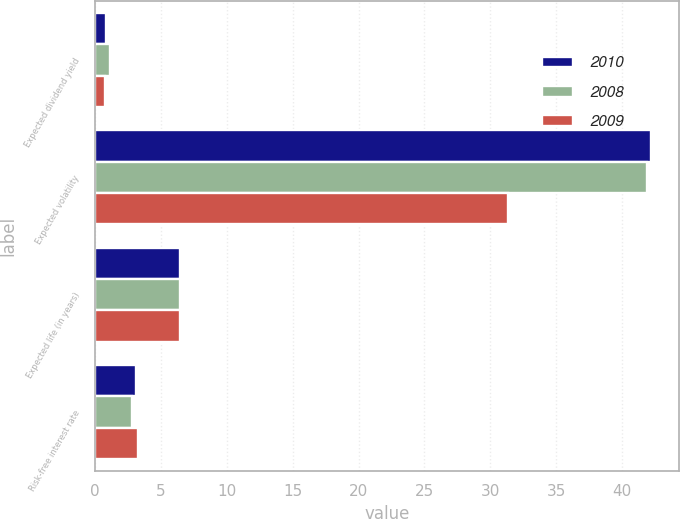Convert chart to OTSL. <chart><loc_0><loc_0><loc_500><loc_500><stacked_bar_chart><ecel><fcel>Expected dividend yield<fcel>Expected volatility<fcel>Expected life (in years)<fcel>Risk-free interest rate<nl><fcel>2010<fcel>0.87<fcel>42.17<fcel>6.5<fcel>3.13<nl><fcel>2008<fcel>1.13<fcel>41.9<fcel>6.5<fcel>2.82<nl><fcel>2009<fcel>0.75<fcel>31.3<fcel>6.5<fcel>3.26<nl></chart> 